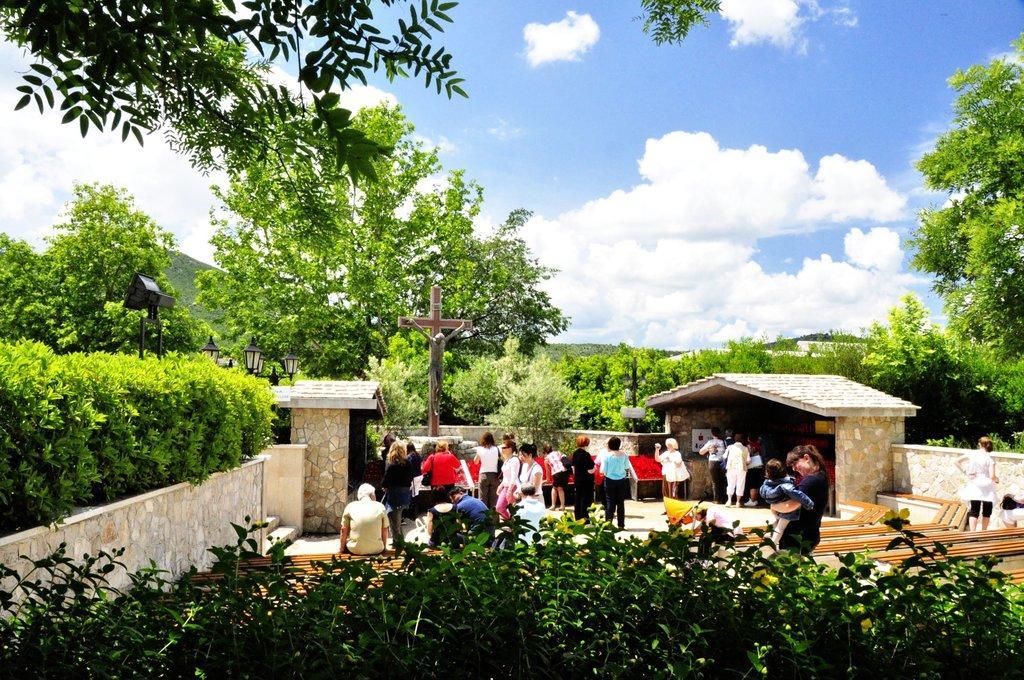Describe this image in one or two sentences. At the bottom I can see plants. In the middle I can see a fence, crowd, poles and trees. On the top I can see the sky. This image is taken during a sunny day. 